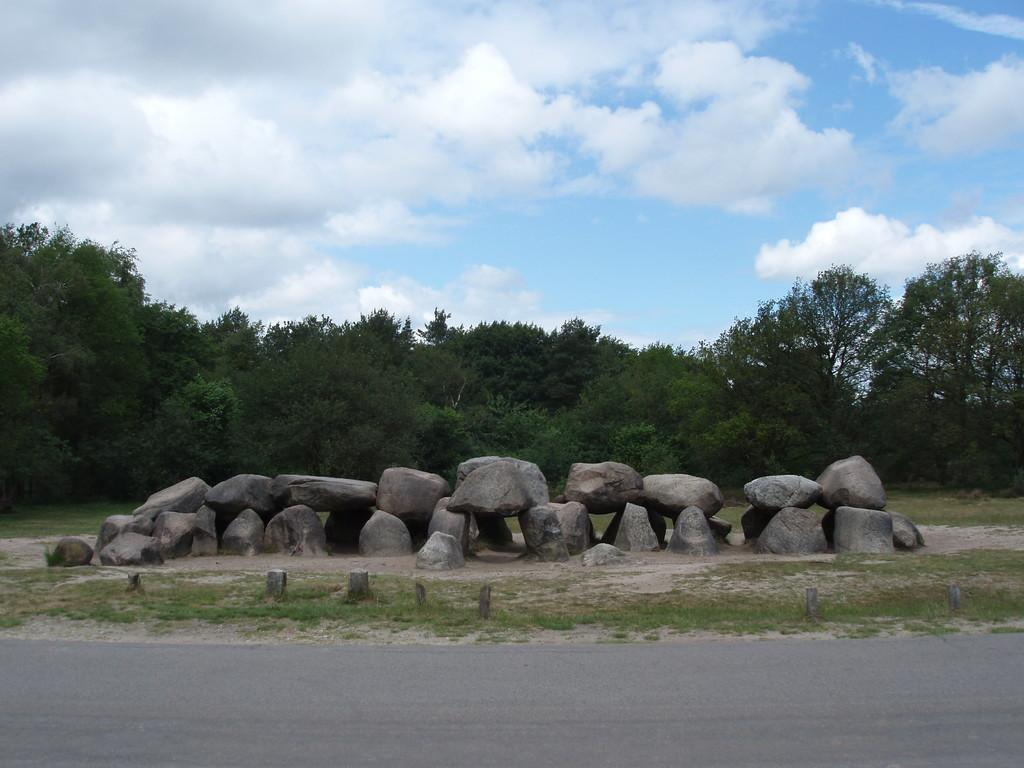What is located in the middle of the image? There are stone rocks in the middle of the image. Where are the stone rocks situated in relation to other elements in the image? The stone rocks are in front of a road. What can be seen in the background of the image? There are trees in the background of the image. What is visible at the top of the image? The sky is visible in the image, and clouds are present in the sky. What type of sponge is being used to clean the stone rocks in the image? There is no sponge present in the image, and the stone rocks are not being cleaned. What is the relation between the stone rocks and the trees in the image? The stone rocks and trees are separate elements in the image, and no direct relation between them is indicated. 